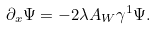<formula> <loc_0><loc_0><loc_500><loc_500>\partial _ { x } \Psi = - 2 \lambda A _ { W } \gamma ^ { 1 } \Psi .</formula> 